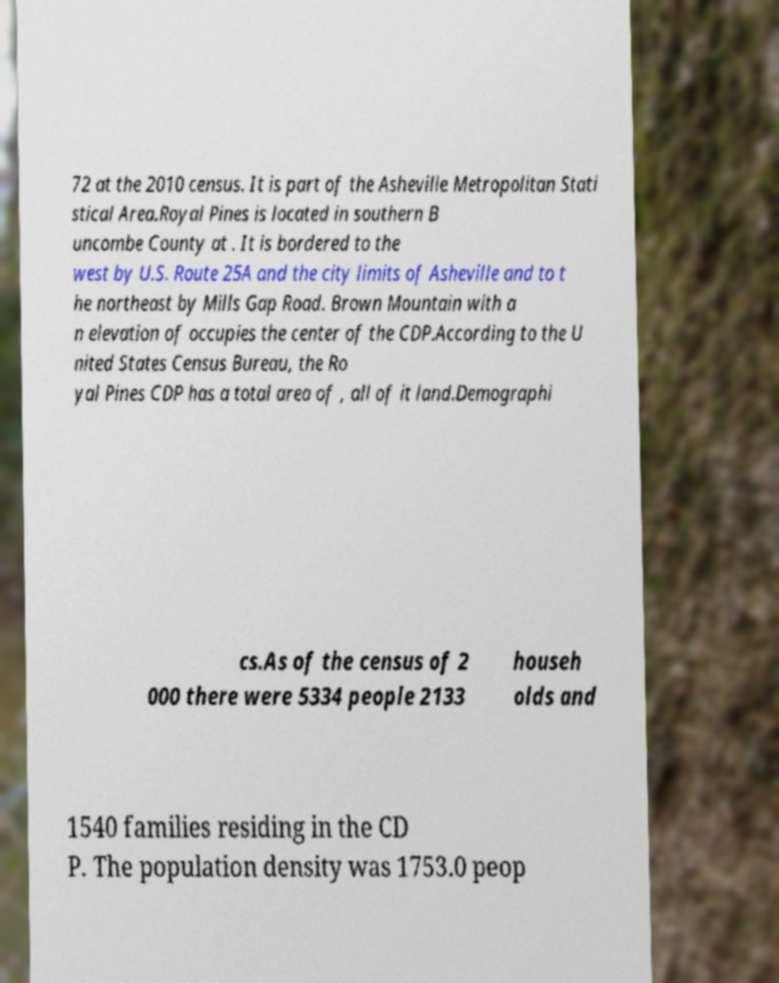Can you read and provide the text displayed in the image?This photo seems to have some interesting text. Can you extract and type it out for me? 72 at the 2010 census. It is part of the Asheville Metropolitan Stati stical Area.Royal Pines is located in southern B uncombe County at . It is bordered to the west by U.S. Route 25A and the city limits of Asheville and to t he northeast by Mills Gap Road. Brown Mountain with a n elevation of occupies the center of the CDP.According to the U nited States Census Bureau, the Ro yal Pines CDP has a total area of , all of it land.Demographi cs.As of the census of 2 000 there were 5334 people 2133 househ olds and 1540 families residing in the CD P. The population density was 1753.0 peop 